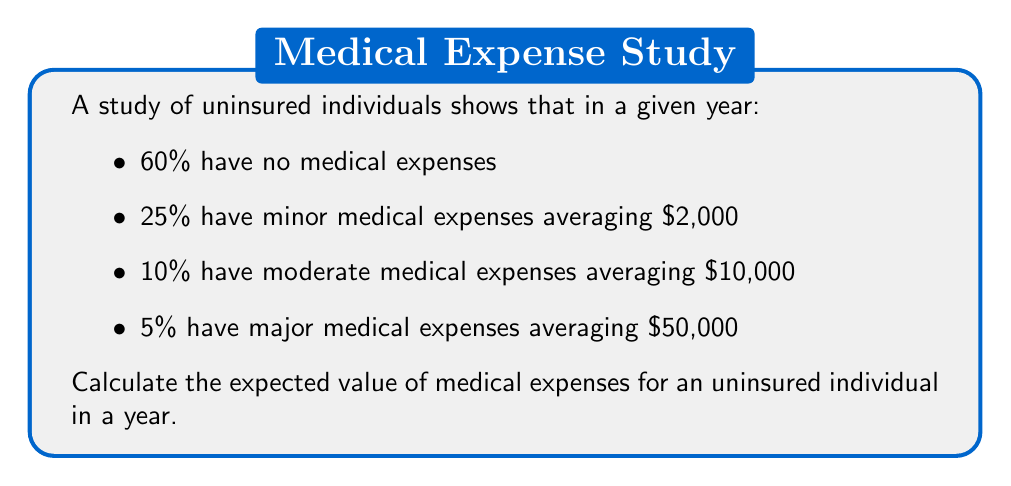Give your solution to this math problem. To calculate the expected value, we need to multiply each possible outcome by its probability and then sum these products.

1) No medical expenses: 
   $0.60 \times $0 = $0

2) Minor medical expenses:
   $0.25 \times $2,000 = $500

3) Moderate medical expenses:
   $0.10 \times $10,000 = $1,000

4) Major medical expenses:
   $0.05 \times $50,000 = $2,500

Now, we sum these values:

$$E(\text{medical expenses}) = $0 + $500 + $1,000 + $2,500 = $4,000$$

Therefore, the expected value of medical expenses for an uninsured individual in a year is $4,000.
Answer: $4,000 